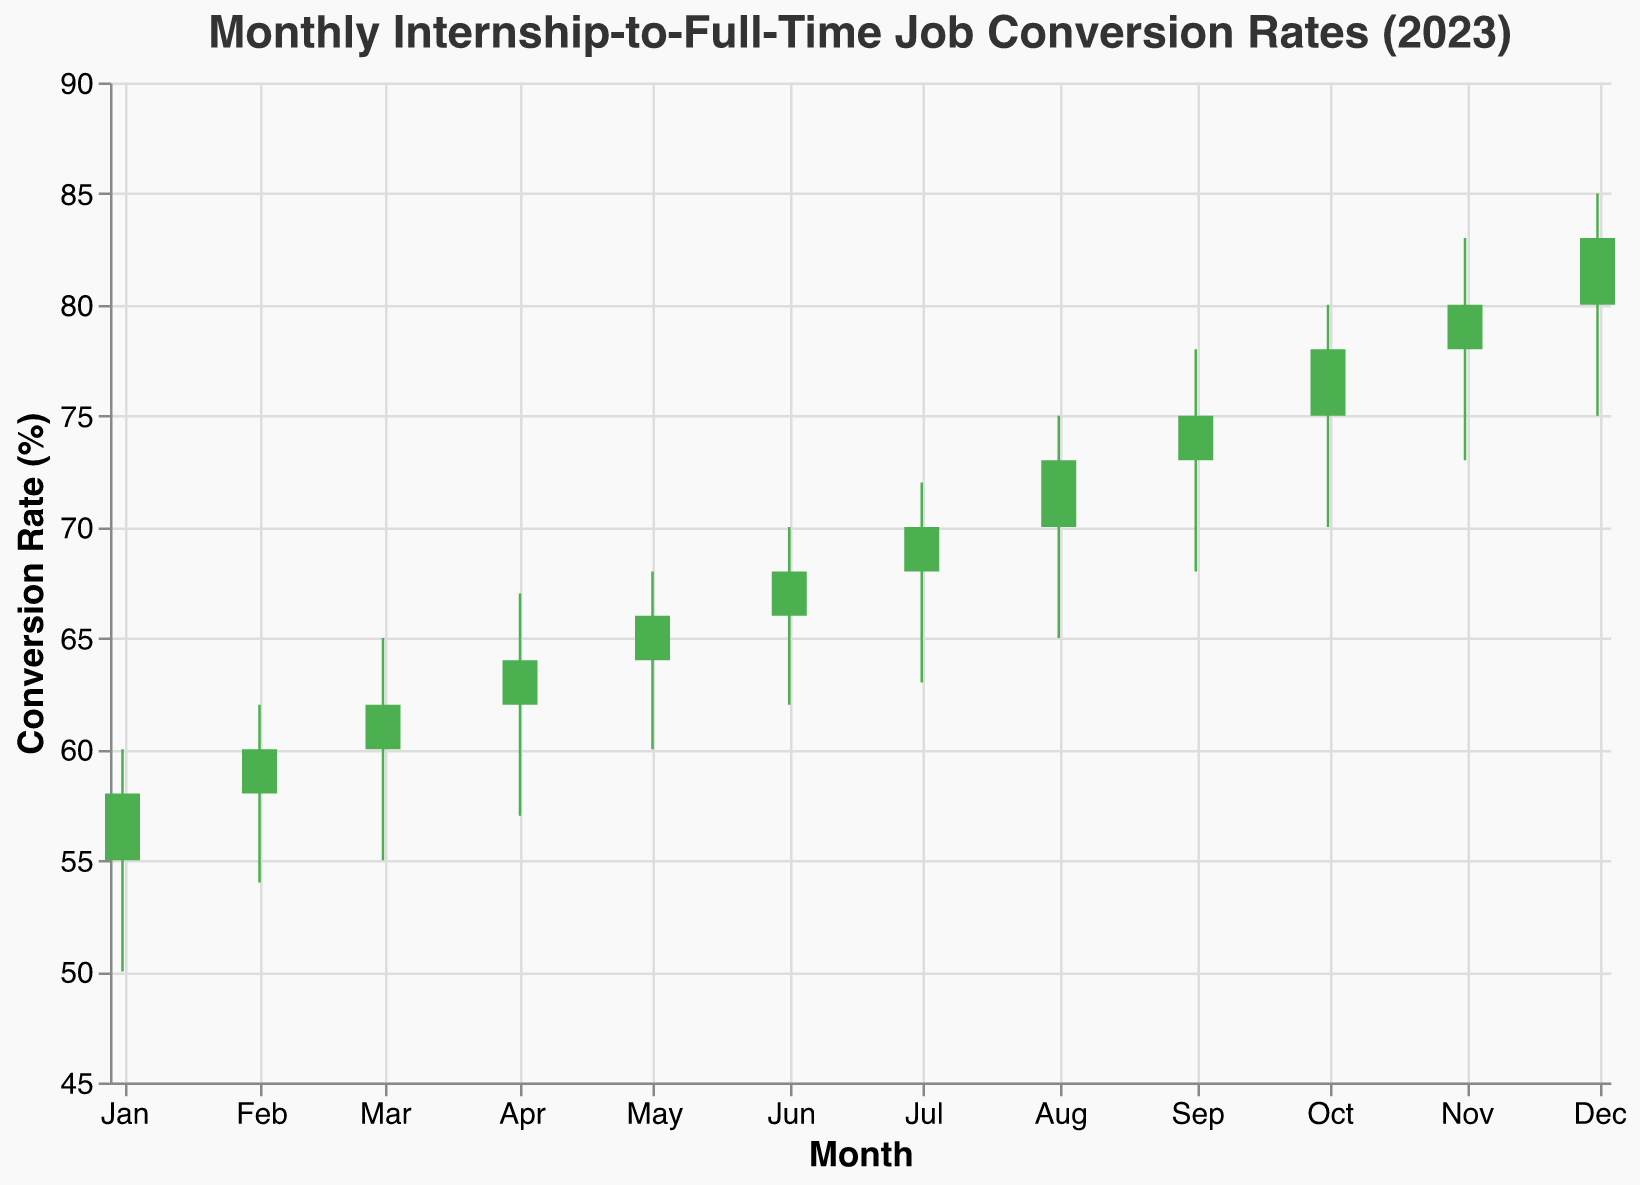What is the title of the plot? The title is displayed at the top of the plot. It reads "Monthly Internship-to-Full-Time Job Conversion Rates (2023)"
Answer: Monthly Internship-to-Full-Time Job Conversion Rates (2023) How many data points are plotted in the figure? Each data point corresponds to one month in 2023. The dates range from January to December, so there are 12 data points.
Answer: 12 Which month has the highest "High" rate? By inspecting the "High" values, December has the highest "High" rate of 85.
Answer: December What is the average "Close" rate for the first quarter (Jan-Mar)? Calculate the average of the "Close" rates for January (58), February (60), and March (62). (58 + 60 + 62) / 3 = 60.
Answer: 60 Which month has the lowest "Low" rate? By inspecting the "Low" values, January has the lowest "Low" rate of 50.
Answer: January Compare the "Open" and "Close" rates in June. Is the conversion rate increasing or decreasing? For June, the "Open" rate is 66 and the "Close" rate is 68, indicating the conversion rate is increasing.
Answer: Increasing How many months experienced a drop in the conversion rate from "Open" to "Close"? Check each month's "Open" and "Close" values. They are January (55 vs 58), February (58 vs 60), March (60 vs 62), April (62 vs 64), May (64 vs 66), June (66 vs 68), July (68 vs 70), August (70 vs 73), September (73 vs 75), October (75 vs 78), November (78 vs 80), December (80 vs 83). No months have a drop.
Answer: 0 What is the range between the highest "High" and the lowest "Low" rates in the entire year? The highest "High" rate is 85 in December, and the lowest "Low" rate is 50 in January. The range is 85 - 50 = 35.
Answer: 35 Which months have a "Close" rate greater than 70? By inspecting the "Close" values, the months with a "Close" rate greater than 70 are August (73), September (75), October (78), November (80), and December (83).
Answer: August, September, October, November, December 